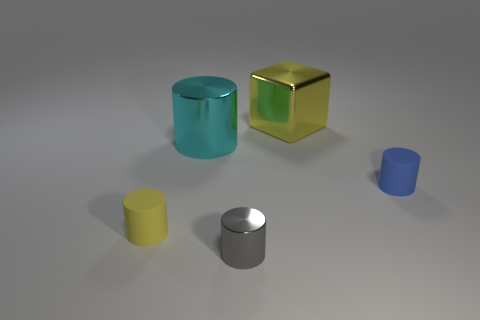Subtract 2 cylinders. How many cylinders are left? 2 Subtract all cyan blocks. Subtract all cyan cylinders. How many blocks are left? 1 Add 4 tiny red matte balls. How many objects exist? 9 Subtract all cylinders. How many objects are left? 1 Subtract all purple cubes. Subtract all tiny blue things. How many objects are left? 4 Add 3 large yellow things. How many large yellow things are left? 4 Add 3 small gray metallic objects. How many small gray metallic objects exist? 4 Subtract 1 blue cylinders. How many objects are left? 4 